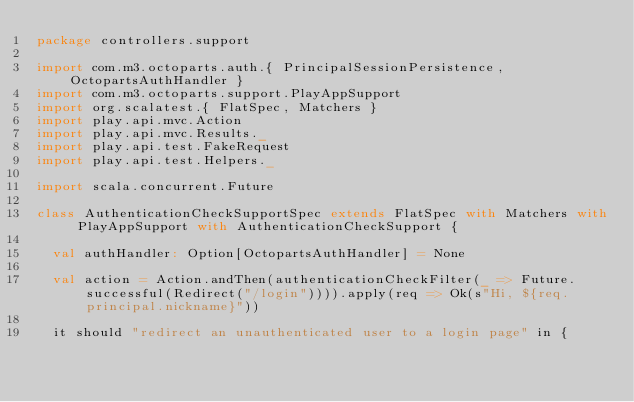Convert code to text. <code><loc_0><loc_0><loc_500><loc_500><_Scala_>package controllers.support

import com.m3.octoparts.auth.{ PrincipalSessionPersistence, OctopartsAuthHandler }
import com.m3.octoparts.support.PlayAppSupport
import org.scalatest.{ FlatSpec, Matchers }
import play.api.mvc.Action
import play.api.mvc.Results._
import play.api.test.FakeRequest
import play.api.test.Helpers._

import scala.concurrent.Future

class AuthenticationCheckSupportSpec extends FlatSpec with Matchers with PlayAppSupport with AuthenticationCheckSupport {

  val authHandler: Option[OctopartsAuthHandler] = None

  val action = Action.andThen(authenticationCheckFilter(_ => Future.successful(Redirect("/login")))).apply(req => Ok(s"Hi, ${req.principal.nickname}"))

  it should "redirect an unauthenticated user to a login page" in {</code> 